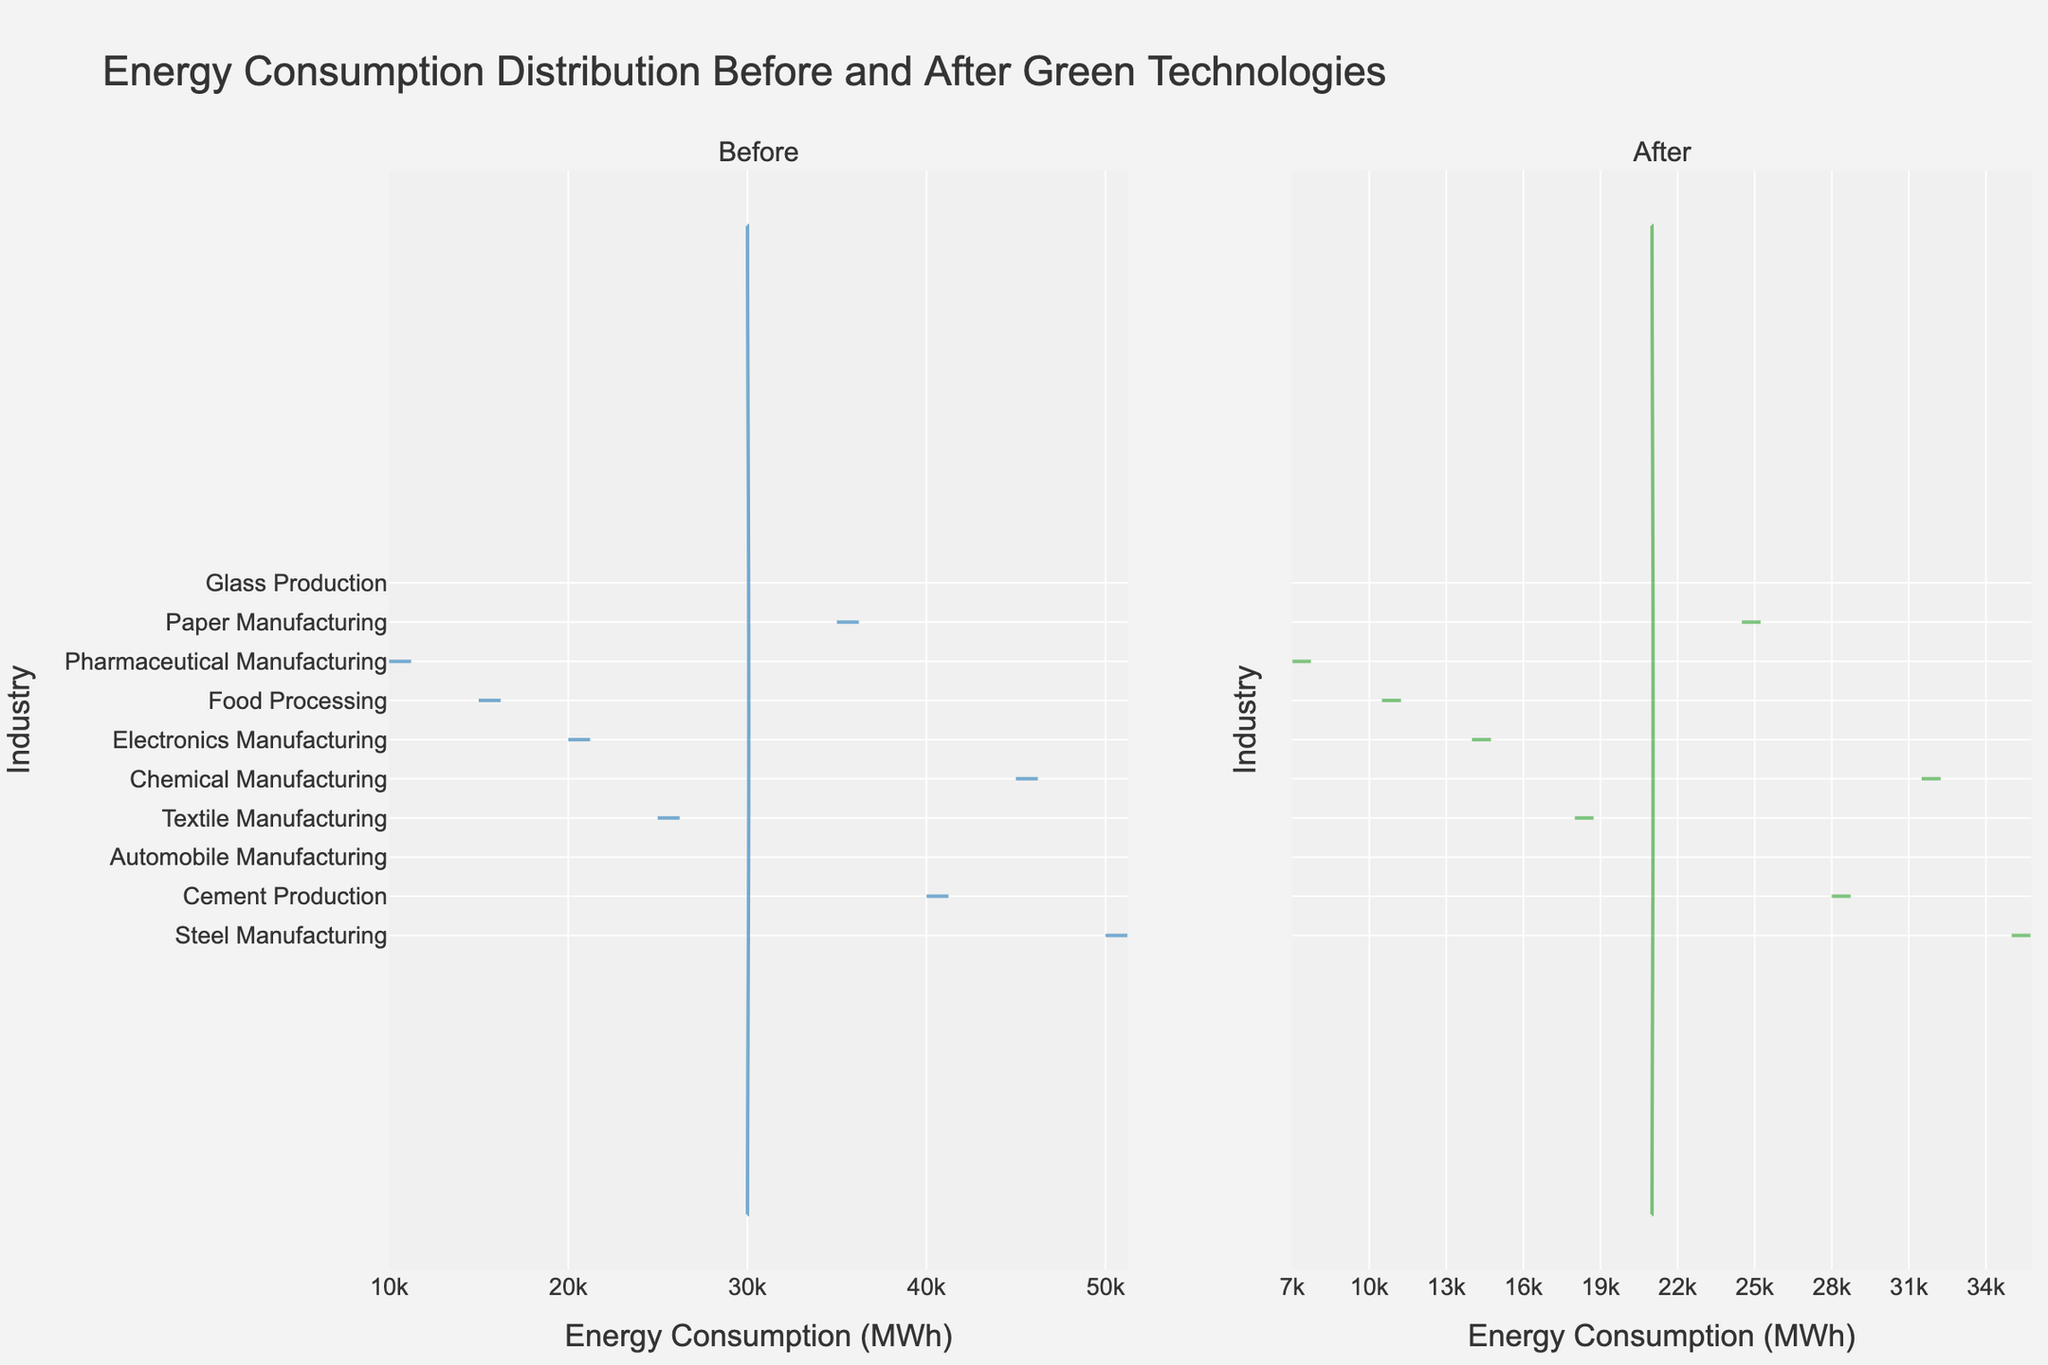What's the title of the figure? The title is displayed at the top center of the figure in large text. It summarizes the plot by describing the energy consumption before and after the implementation of green technologies in various industries.
Answer: Energy Consumption Distribution Before and After Green Technologies Which industry has the highest energy consumption before the implementation of green technologies? Looking at the y-axis labels on the left-hand side (Before section), the Steel Manufacturing industry has the highest energy consumption which is the furthest to the right.
Answer: Steel Manufacturing What is the energy consumption of Pharmaceutical Manufacturing after implementing green technologies? On the y-axis, find Pharmaceutical Manufacturing and look to the right section (After). The energy consumption is at 7,000 MWh.
Answer: 7,000 MWh How much energy was saved in the Cement Production industry after implementing green technologies? The difference between the before and after values shows the energy saved. For Cement Production, the energy consumption drops from 40,000 MWh to 28,000 MWh. So, 40,000 - 28,000 equals 12,000 MWh saved.
Answer: 12,000 MWh Rank the top three industries in terms of energy savings after implementing green technologies. To determine the energy savings, subtract the after values from the before values for each industry. The top three savings are:
1. Steel Manufacturing: 50,000 - 35,000 = 15,000 MWh
2. Cement Production: 40,000 - 28,000 = 12,000 MWh
3. Automobile Manufacturing: 30,000 - 21,000 = 9,000 MWh
Answer: 1. Steel Manufacturing, 2. Cement Production, 3. Automobile Manufacturing Is the energy consumption of Glass Production before green technologies greater than that of Textile Manufacturing before green technologies? Compare the positions along the x-axis in the Before section for both industries. Glass Production is at 30,000 MWh, while Textile Manufacturing is at 25,000 MWh.
Answer: Yes Which industry exhibits the smallest reduction in energy consumption? Compare the differences between before and after for each industry. The smallest difference is for Pharmaceutical Manufacturing with a reduction from 10,000 MWh to 7,000 MWh, saving 3,000 MWh.
Answer: Pharmaceutical Manufacturing What is the combined energy consumption of Food Processing and Electronics Manufacturing after green technologies implementation? Add the after values for both industries. Food Processing has 10,500 MWh and Electronics Manufacturing has 14,000 MWh. Thus, 10,500 + 14,000 = 24,500 MWh.
Answer: 24,500 MWh Compare the energy consumption distributions of the Textile and Chemical Manufacturing industries before and after the implementation of green technologies. Which one shows a greater percentage reduction? Calculate the percentage reduction for both:
- Textile Manufacturing: (25,000 - 18,000) / 25,000 * 100 = 28%
- Chemical Manufacturing: (45,000 - 31,500) / 45,000 * 100 = 30%
Chemical Manufacturing shows a greater percentage reduction than Textile Manufacturing.
Answer: Chemical Manufacturing Do any industries have the same energy consumption both before and after the implementation of green technologies? Look at both sections of the plot and compare values. All industries show different energy consumptions before and after.
Answer: No 